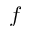<formula> <loc_0><loc_0><loc_500><loc_500>f</formula> 